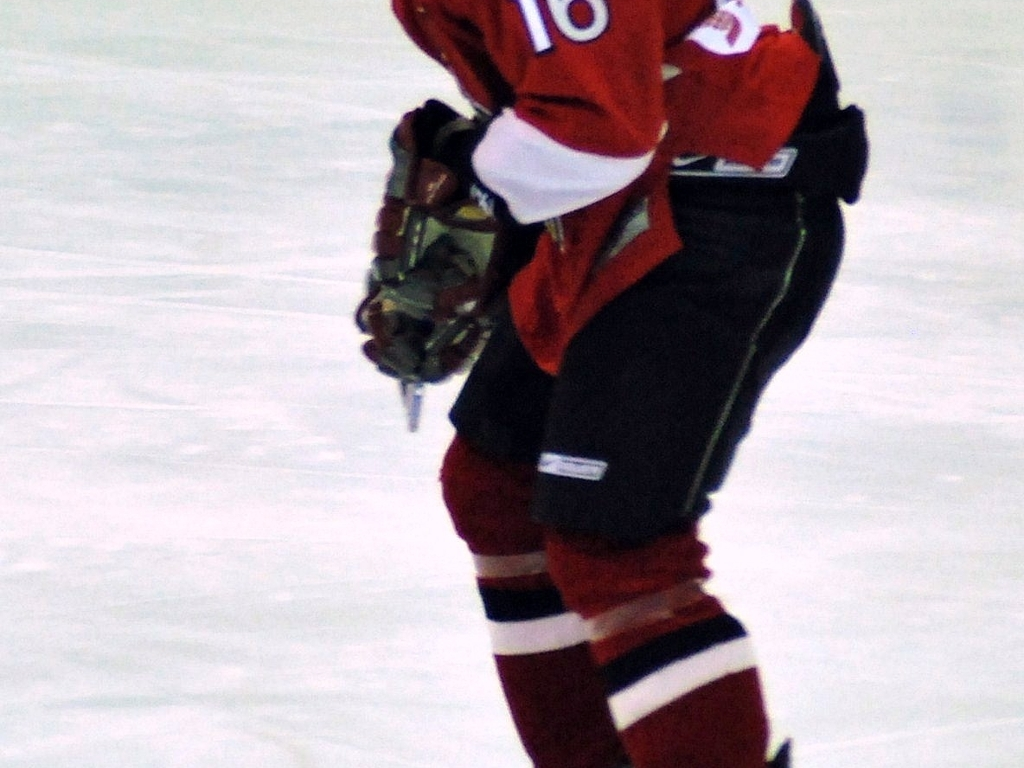Is there strong noise present in the image? The image does exhibit noticeable noise, indicated by the grainy texture apparent in the darker areas and around the figure, which can detract from the image's clarity. 